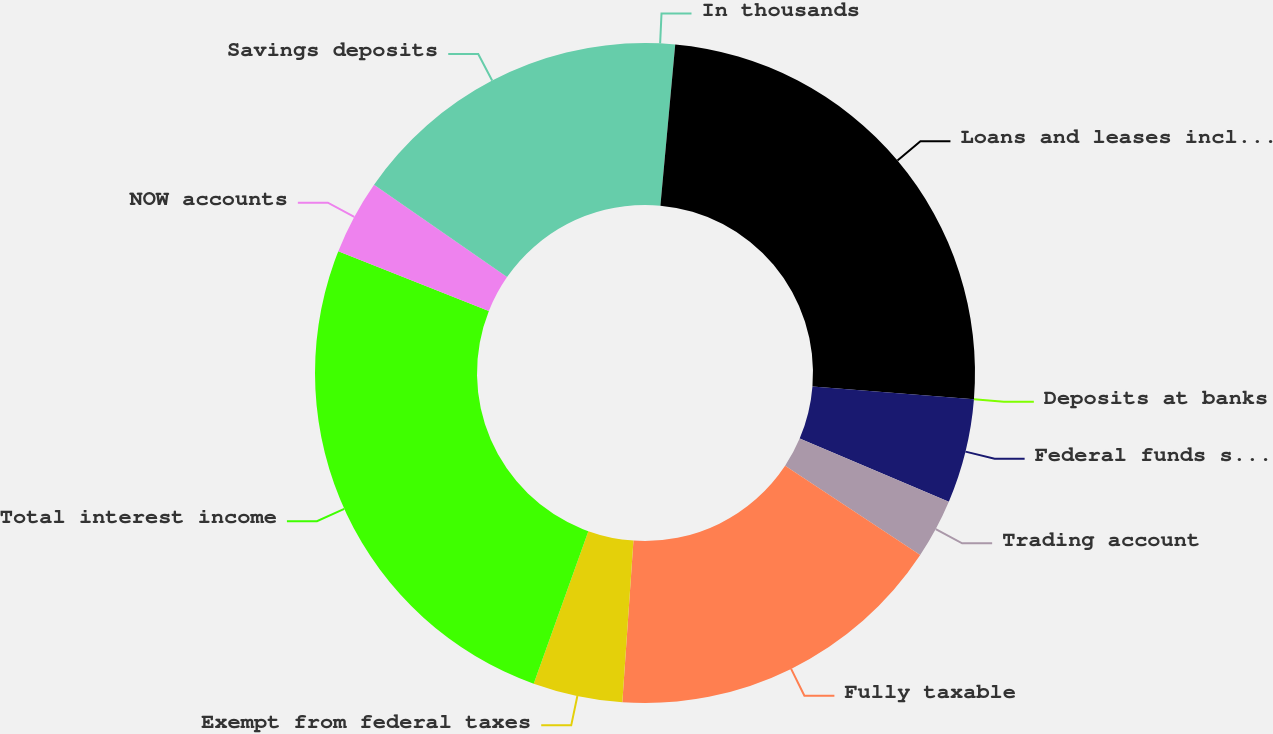Convert chart. <chart><loc_0><loc_0><loc_500><loc_500><pie_chart><fcel>In thousands<fcel>Loans and leases including<fcel>Deposits at banks<fcel>Federal funds sold and resell<fcel>Trading account<fcel>Fully taxable<fcel>Exempt from federal taxes<fcel>Total interest income<fcel>NOW accounts<fcel>Savings deposits<nl><fcel>1.46%<fcel>24.81%<fcel>0.0%<fcel>5.11%<fcel>2.92%<fcel>16.79%<fcel>4.38%<fcel>25.54%<fcel>3.65%<fcel>15.33%<nl></chart> 